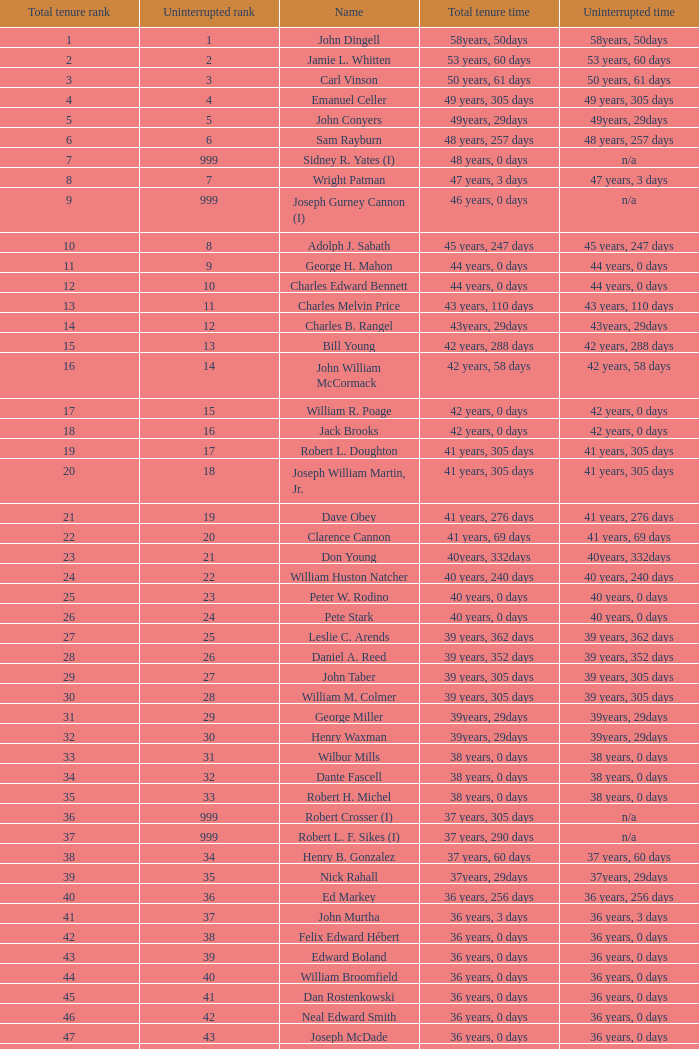How many consecutive ranks does john dingell possess? 1.0. 